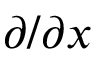<formula> <loc_0><loc_0><loc_500><loc_500>\partial / \partial x</formula> 